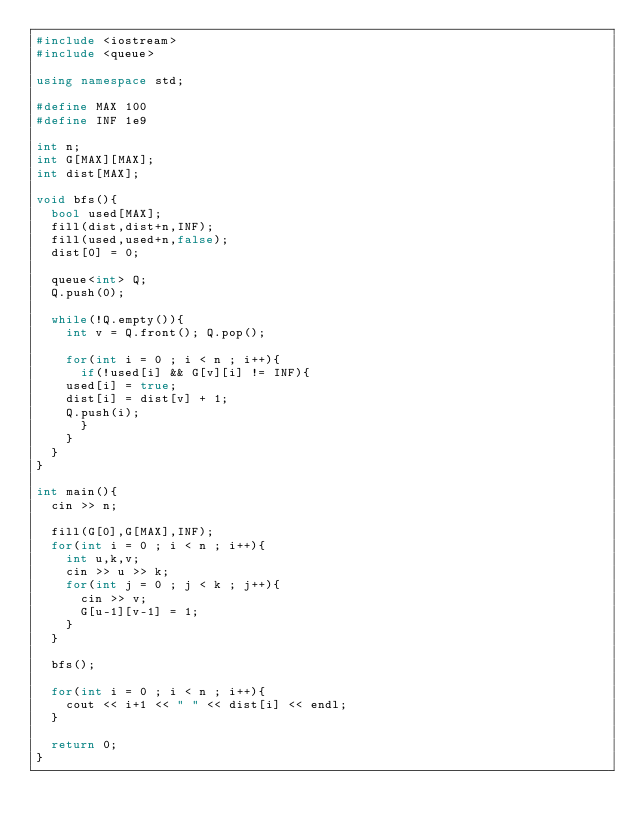<code> <loc_0><loc_0><loc_500><loc_500><_C++_>#include <iostream>
#include <queue>

using namespace std;

#define MAX 100
#define INF 1e9

int n;
int G[MAX][MAX];
int dist[MAX];

void bfs(){
  bool used[MAX];
  fill(dist,dist+n,INF);
  fill(used,used+n,false);
  dist[0] = 0;

  queue<int> Q;
  Q.push(0);

  while(!Q.empty()){
    int v = Q.front(); Q.pop();

    for(int i = 0 ; i < n ; i++){
      if(!used[i] && G[v][i] != INF){
	used[i] = true;
	dist[i] = dist[v] + 1;
	Q.push(i);
      }
    }
  }
}

int main(){
  cin >> n;

  fill(G[0],G[MAX],INF);
  for(int i = 0 ; i < n ; i++){
    int u,k,v;
    cin >> u >> k;
    for(int j = 0 ; j < k ; j++){
      cin >> v;
      G[u-1][v-1] = 1;
    }
  }

  bfs();

  for(int i = 0 ; i < n ; i++){
    cout << i+1 << " " << dist[i] << endl;
  }

  return 0;
}</code> 